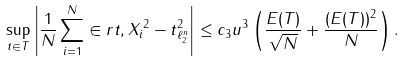<formula> <loc_0><loc_0><loc_500><loc_500>\sup _ { t \in T } \left | \frac { 1 } { N } \sum _ { i = 1 } ^ { N } \in r { t , X _ { i } } ^ { 2 } - \| t \| _ { \ell _ { 2 } ^ { n } } ^ { 2 } \right | \leq c _ { 3 } u ^ { 3 } \left ( \frac { E ( T ) } { \sqrt { N } } + \frac { ( E ( T ) ) ^ { 2 } } { N } \right ) .</formula> 